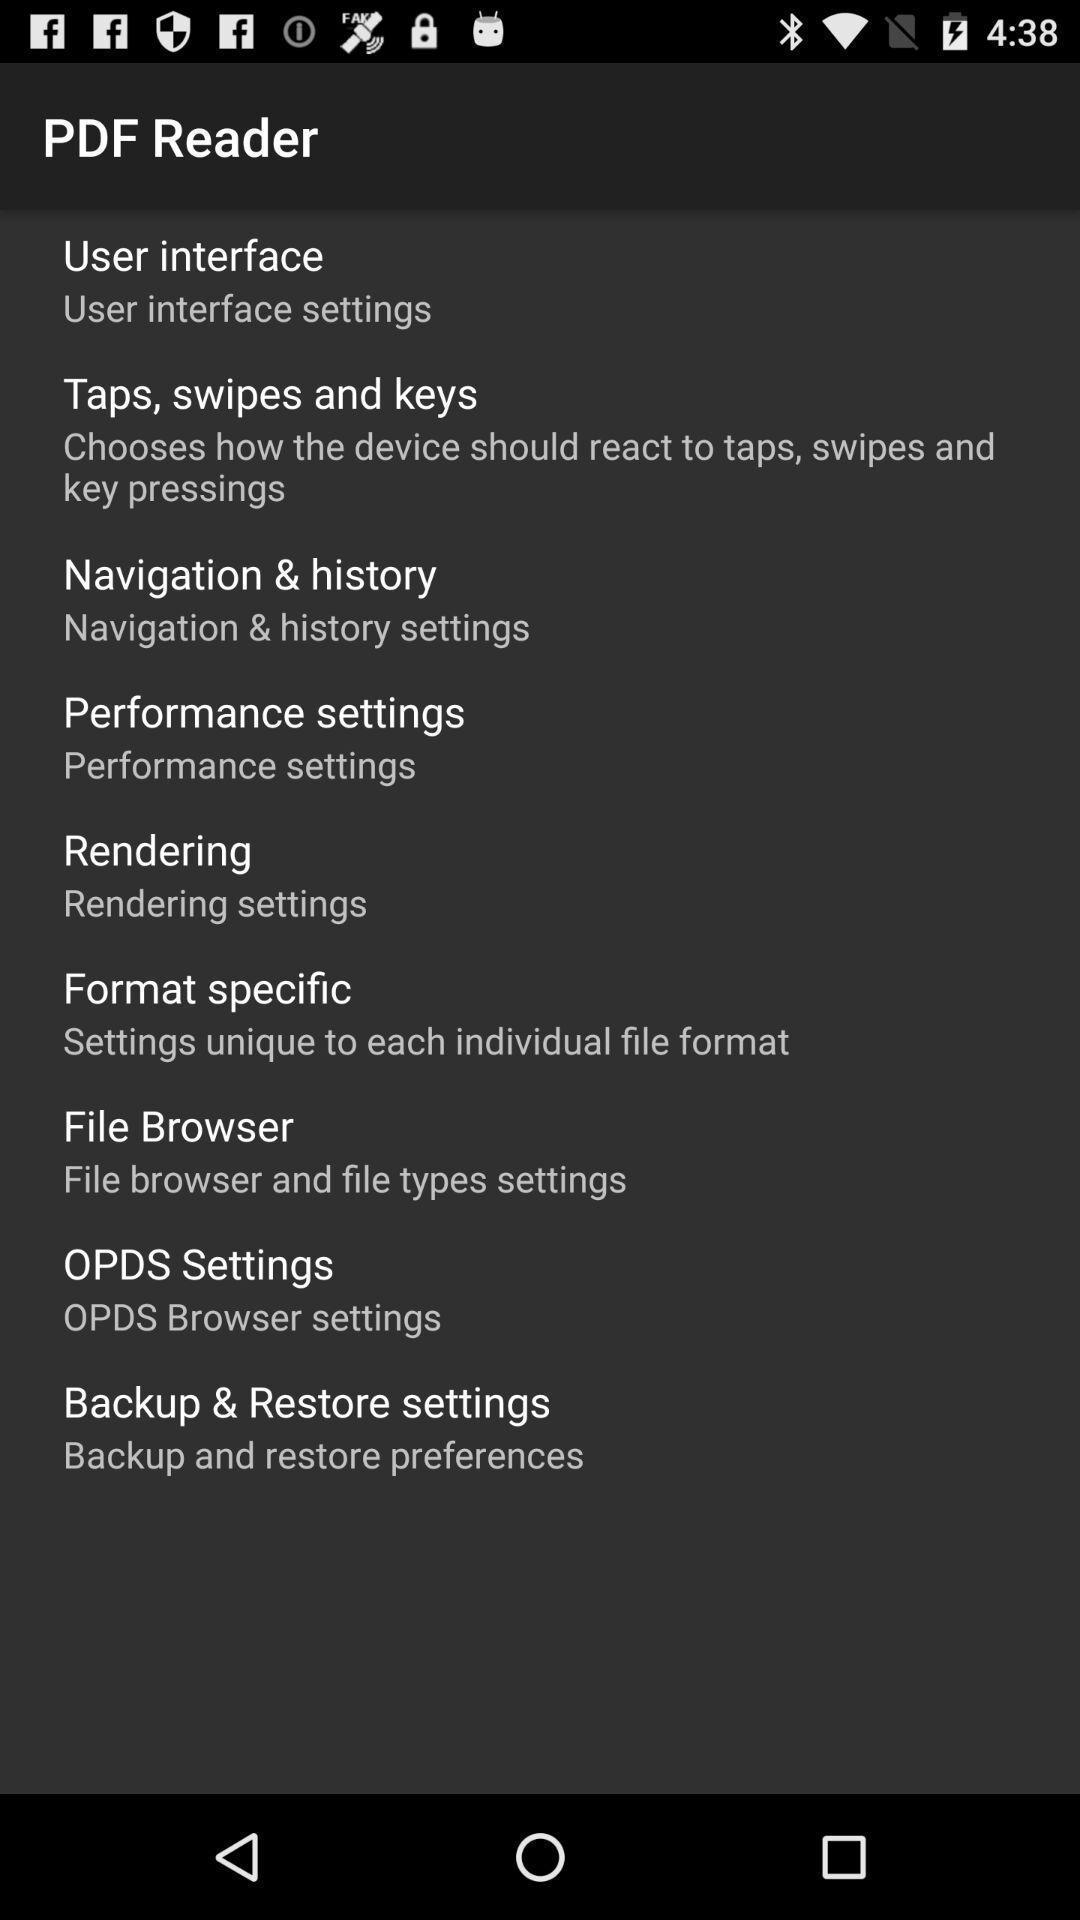Provide a textual representation of this image. Screen showing page. 